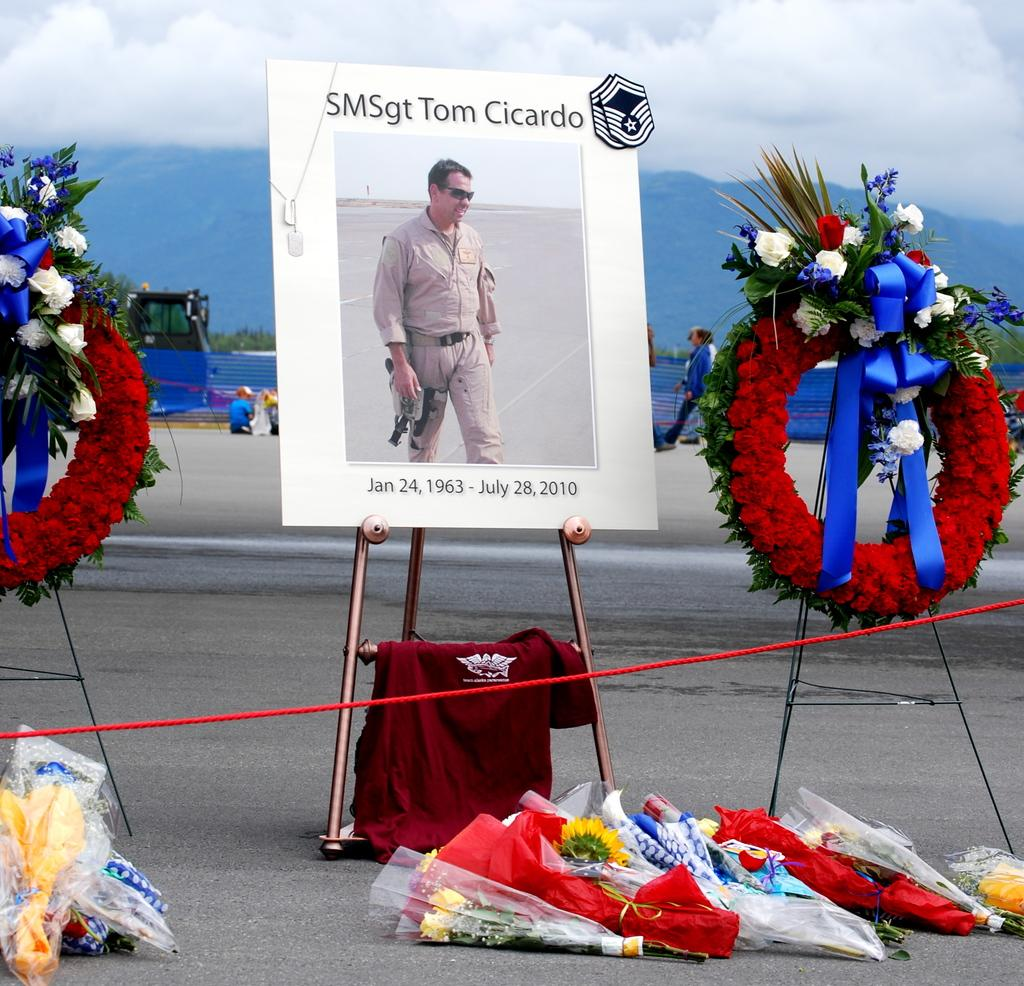What type of business is depicted in the image? There is a bouquet shop in the image. What can be found inside the shop? There are many bouquets in the shop. What is located in the middle of the image? There is a stand and a board in the middle of the image. What is visible in the background of the image? The sky is visible in the background of the image. What is the condition of the sky in the image? The sky is full of clouds in the image. How many eyes can be seen on the bouquets in the image? There are no eyes present on the bouquets in the image, as bouquets are made of flowers and do not have eyes. What day of the week is it in the image? The image does not provide any information about the day of the week. Is there a competition taking place in the bouquet shop in the image? There is no indication of a competition taking place in the bouquet shop in the image. 